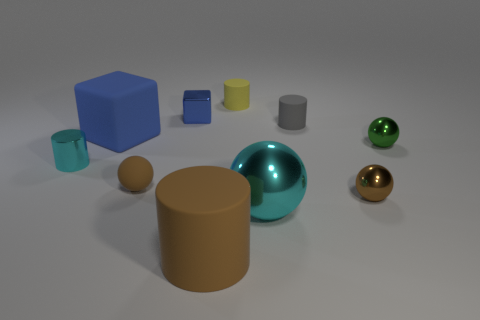Subtract 1 cylinders. How many cylinders are left? 3 Subtract all cubes. How many objects are left? 8 Subtract all tiny brown metallic objects. Subtract all green metal objects. How many objects are left? 8 Add 2 small cyan shiny things. How many small cyan shiny things are left? 3 Add 6 cyan spheres. How many cyan spheres exist? 7 Subtract 1 gray cylinders. How many objects are left? 9 